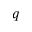Convert formula to latex. <formula><loc_0><loc_0><loc_500><loc_500>{ q }</formula> 